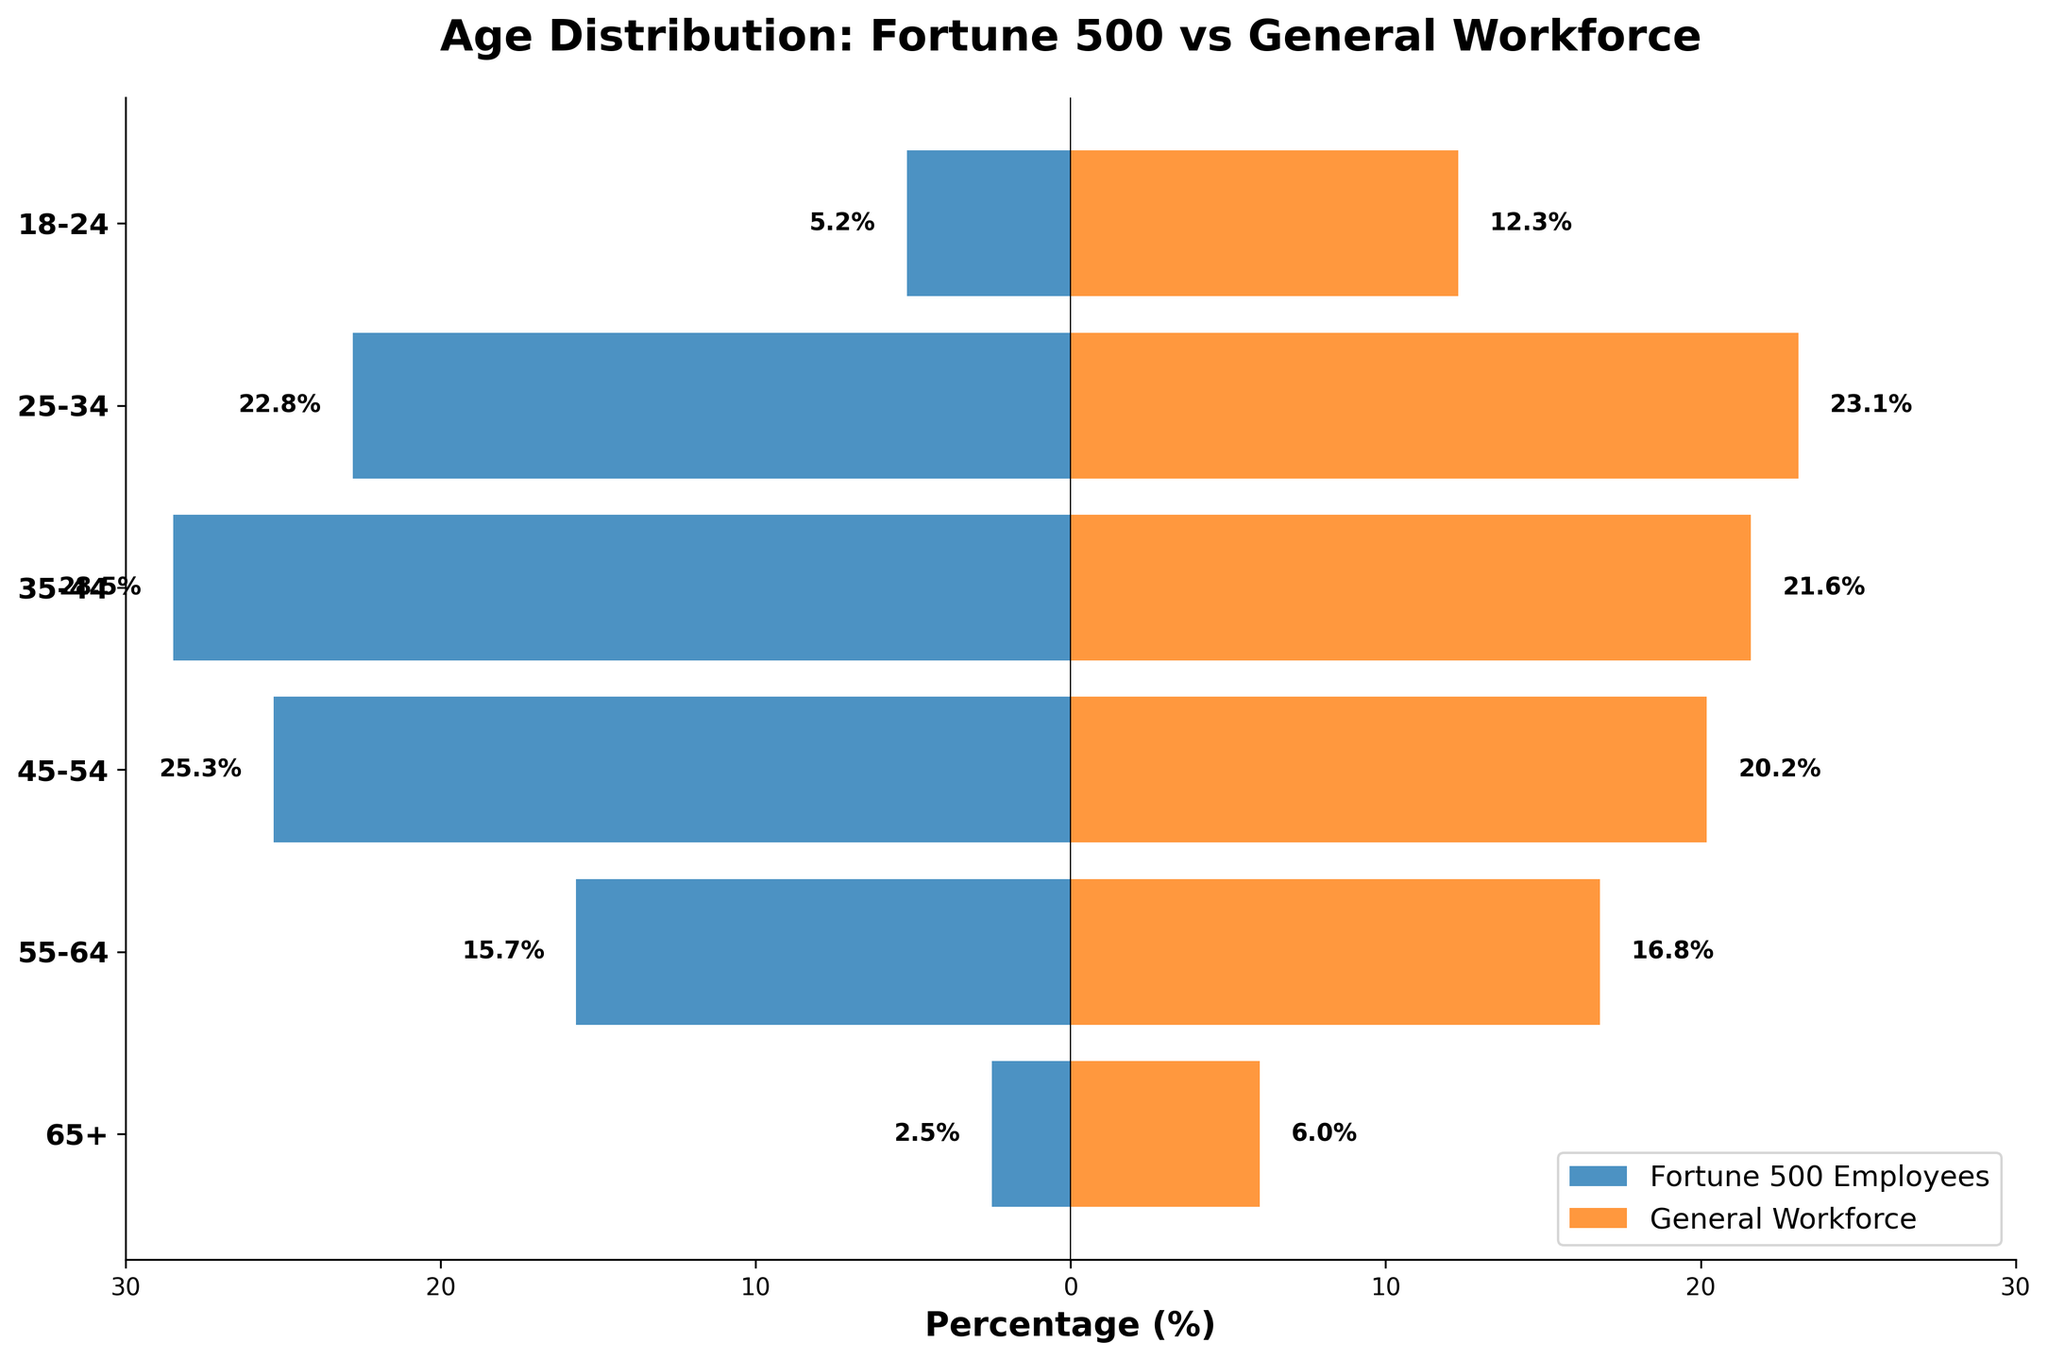What is the age group with the highest percentage of Fortune 500 employees? The bar representing the age group with the highest percentage of Fortune 500 employees is the longest towards the negative side. The '35-44' age group's bar reaches -28.5%.
Answer: 35-44 What is the title of the figure? The title is displayed at the top of the figure. It reads "Age Distribution: Fortune 500 vs General Workforce".
Answer: Age Distribution: Fortune 500 vs General Workforce Which age group has a higher percentage in the general workforce compared to Fortune 500 employees? Comparing the lengths of the bars for Fortune 500 and general workforce, the '18-24' and '65+' age groups show higher percentages in the general workforce at 12.3% and 6.0% respectively, compared to 5.2% and 2.5% for Fortune 500.
Answer: 18-24 and 65+ What is the difference in percentage between the '45-54' age group in Fortune 500 employees and general workforce? The percentage for the '45-54' age group in Fortune 500 employees is 25.3%, and for the general workforce, it is 20.2%. The difference is 25.3% - 20.2% = 5.1%.
Answer: 5.1% How does the percentage of Fortune 500 employees in the '55-64' age group compare to those in the '35-44' age group? The bar for the '35-44' age group (28.5%) is longer than the bar for the '55-64' age group (15.7%), indicating that the percentage in the '35-44' group is higher.
Answer: 35-44 > 55-64 Which age group has nearly the same percentage for both Fortune 500 employees and the general workforce? Comparing the bars, the '25-34' age group has percentages of 22.8% for Fortune 500 employees and 23.1% for the general workforce, which are nearly the same.
Answer: 25-34 Is the percentage of the '18-24' age group higher than the '65+' age group in the general workforce? The bar for the '18-24' age group in the general workforce (12.3%) is longer than the bar for the '65+' age group (6.0%), indicating it is higher.
Answer: Yes What is the combined percentage of Fortune 500 employees in the '35-44' and '45-54' age groups? Adding the percentages of the '35-44' (28.5%) and '45-54' (25.3%) age groups gives 28.5% + 25.3% = 53.8%.
Answer: 53.8% What is the range of percentages shown on the x-axis? The x-axis ranges from -30% to 30%, as indicated by the tick marks and labels.
Answer: -30% to 30% 